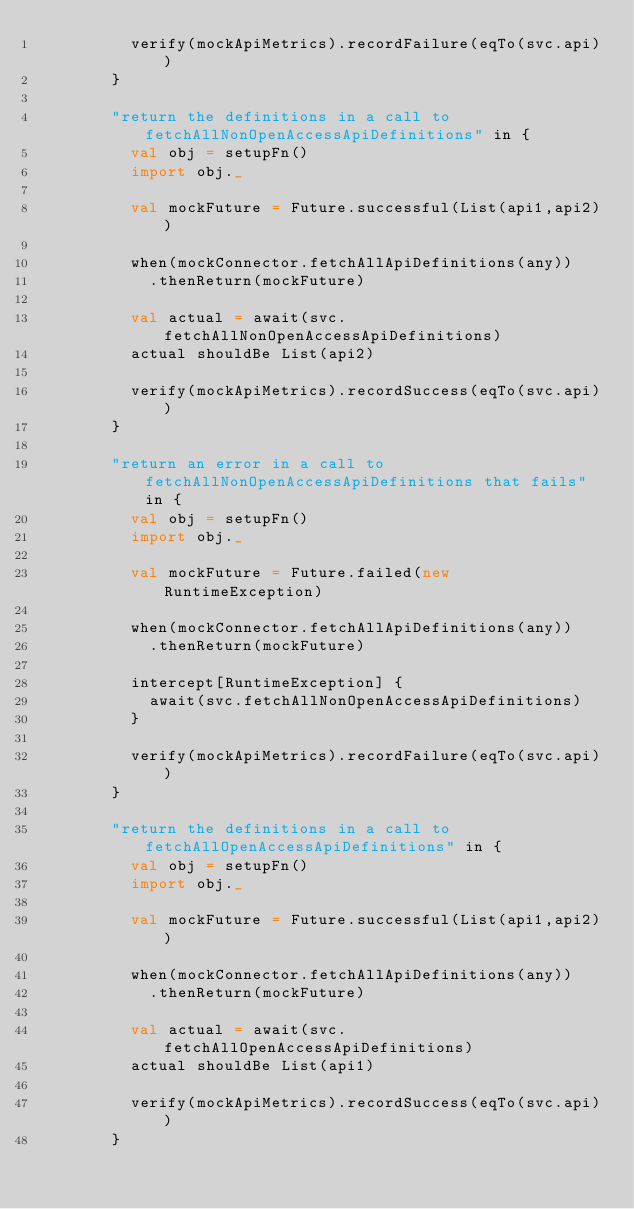Convert code to text. <code><loc_0><loc_0><loc_500><loc_500><_Scala_>          verify(mockApiMetrics).recordFailure(eqTo(svc.api))
        }

        "return the definitions in a call to fetchAllNonOpenAccessApiDefinitions" in {
          val obj = setupFn()
          import obj._

          val mockFuture = Future.successful(List(api1,api2))

          when(mockConnector.fetchAllApiDefinitions(any))
            .thenReturn(mockFuture)

          val actual = await(svc.fetchAllNonOpenAccessApiDefinitions)
          actual shouldBe List(api2)

          verify(mockApiMetrics).recordSuccess(eqTo(svc.api))
        }

        "return an error in a call to fetchAllNonOpenAccessApiDefinitions that fails" in {
          val obj = setupFn()
          import obj._

          val mockFuture = Future.failed(new RuntimeException)

          when(mockConnector.fetchAllApiDefinitions(any))
            .thenReturn(mockFuture)

          intercept[RuntimeException] {
            await(svc.fetchAllNonOpenAccessApiDefinitions)
          }

          verify(mockApiMetrics).recordFailure(eqTo(svc.api))
        }

        "return the definitions in a call to fetchAllOpenAccessApiDefinitions" in {
          val obj = setupFn()
          import obj._

          val mockFuture = Future.successful(List(api1,api2))

          when(mockConnector.fetchAllApiDefinitions(any))
            .thenReturn(mockFuture)

          val actual = await(svc.fetchAllOpenAccessApiDefinitions)
          actual shouldBe List(api1)

          verify(mockApiMetrics).recordSuccess(eqTo(svc.api))
        }
</code> 